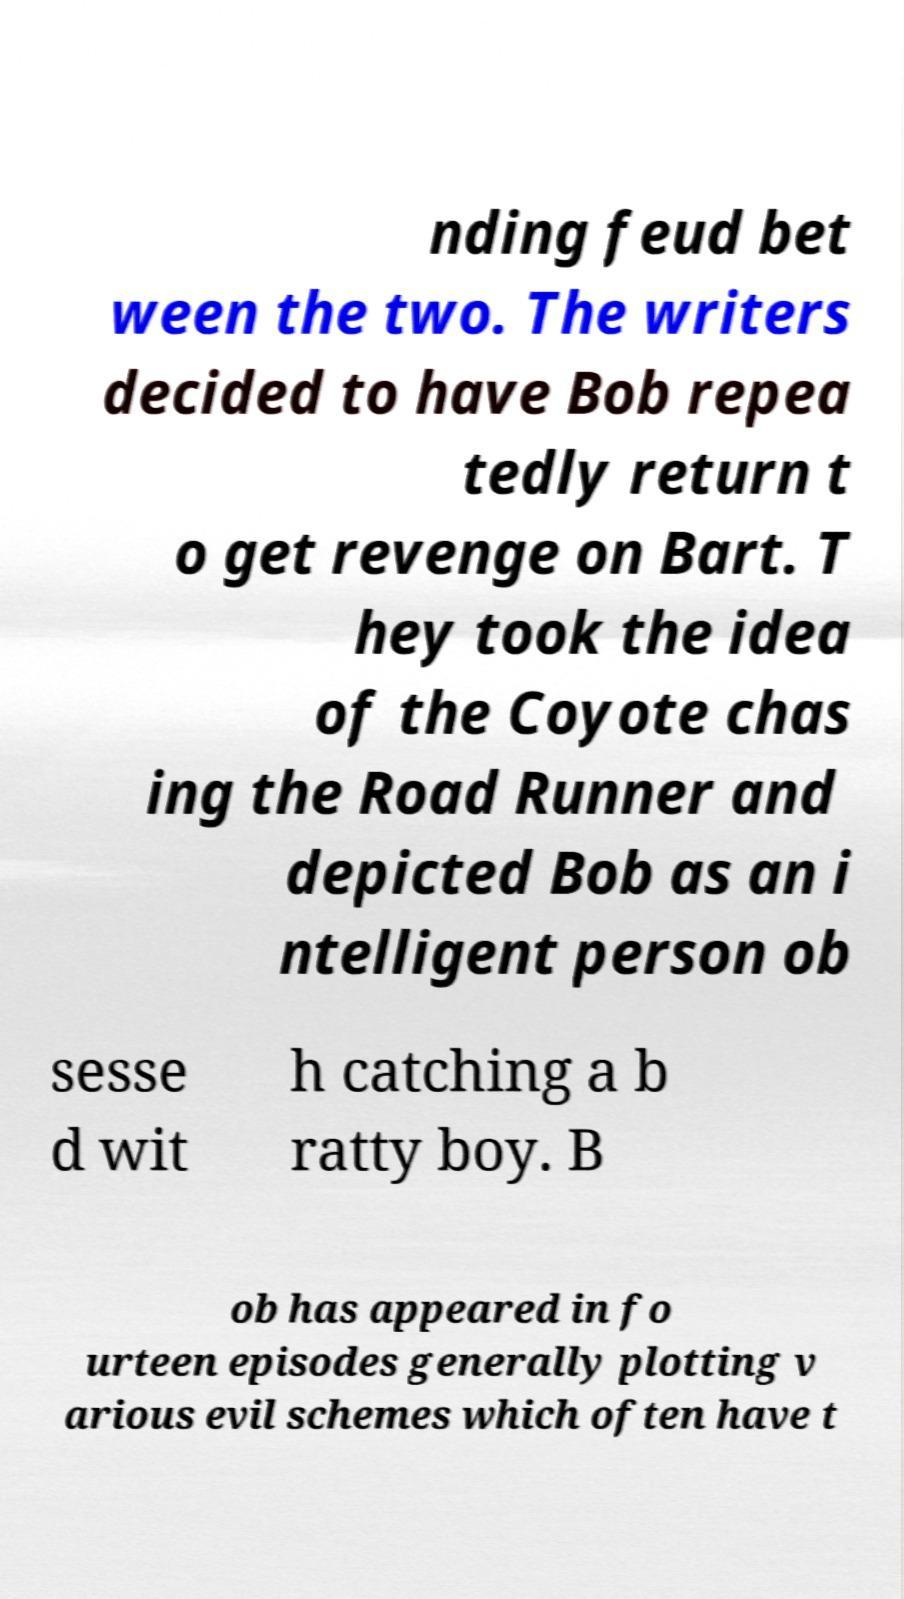Could you assist in decoding the text presented in this image and type it out clearly? nding feud bet ween the two. The writers decided to have Bob repea tedly return t o get revenge on Bart. T hey took the idea of the Coyote chas ing the Road Runner and depicted Bob as an i ntelligent person ob sesse d wit h catching a b ratty boy. B ob has appeared in fo urteen episodes generally plotting v arious evil schemes which often have t 